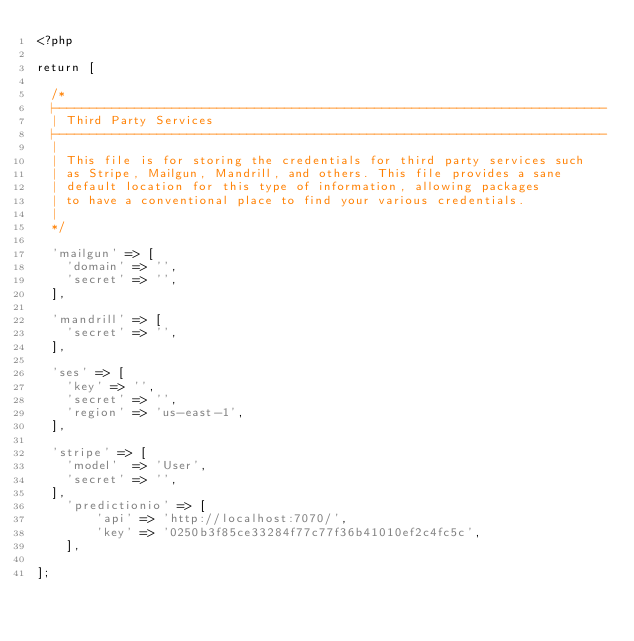Convert code to text. <code><loc_0><loc_0><loc_500><loc_500><_PHP_><?php

return [

	/*
	|--------------------------------------------------------------------------
	| Third Party Services
	|--------------------------------------------------------------------------
	|
	| This file is for storing the credentials for third party services such
	| as Stripe, Mailgun, Mandrill, and others. This file provides a sane
	| default location for this type of information, allowing packages
	| to have a conventional place to find your various credentials.
	|
	*/

	'mailgun' => [
		'domain' => '',
		'secret' => '',
	],

	'mandrill' => [
		'secret' => '',
	],

	'ses' => [
		'key' => '',
		'secret' => '',
		'region' => 'us-east-1',
	],

	'stripe' => [
		'model'  => 'User',
		'secret' => '',
	],
    'predictionio' => [
        'api' => 'http://localhost:7070/',
        'key' => '0250b3f85ce33284f77c77f36b41010ef2c4fc5c',
    ],

];
</code> 